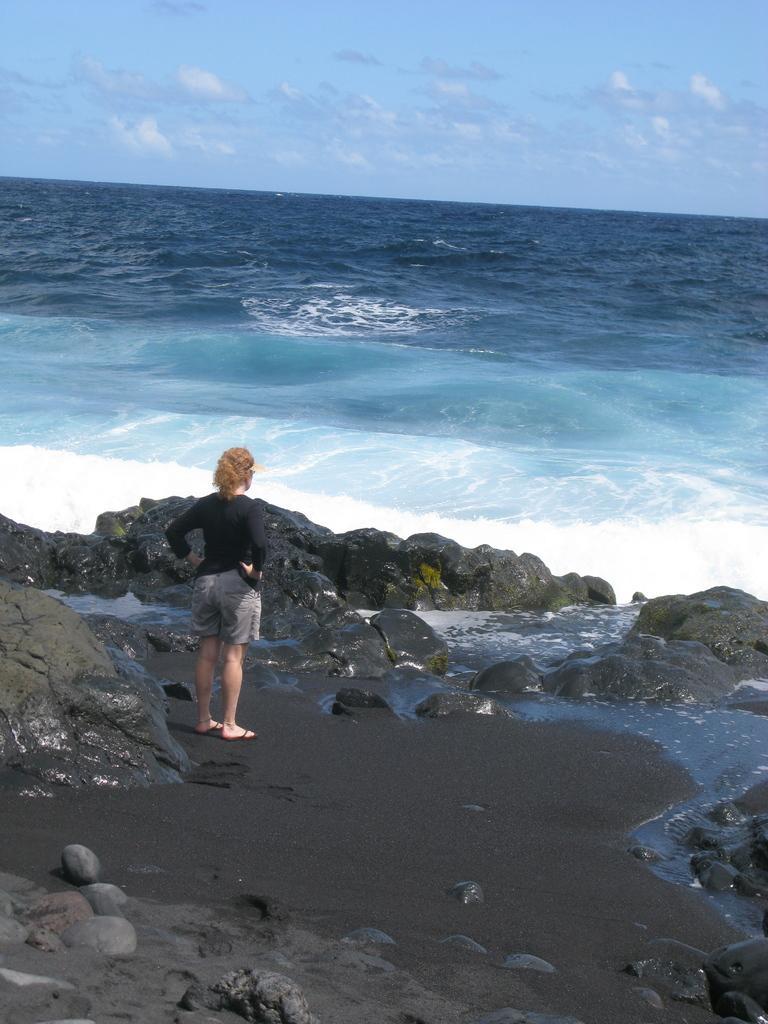In one or two sentences, can you explain what this image depicts? This image is taken in the beach. In this image we can see a woman standing. We are also see the rocks. Sky is also visible with the clouds. 